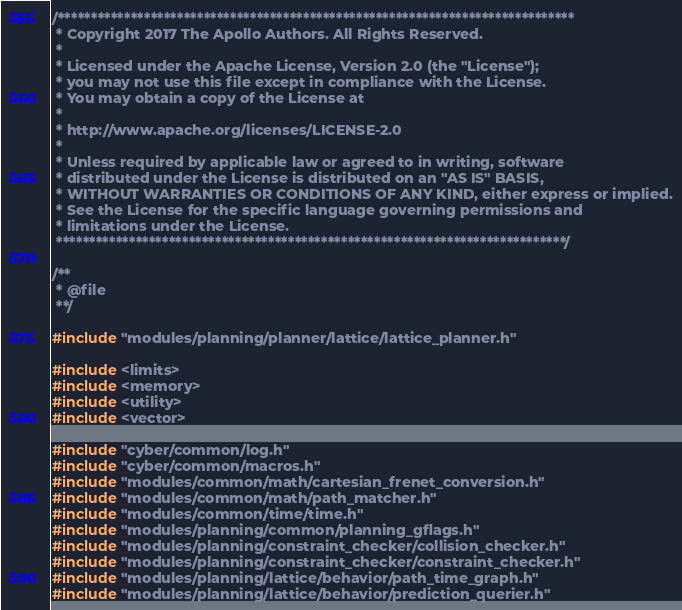<code> <loc_0><loc_0><loc_500><loc_500><_C++_>/******************************************************************************
 * Copyright 2017 The Apollo Authors. All Rights Reserved.
 *
 * Licensed under the Apache License, Version 2.0 (the "License");
 * you may not use this file except in compliance with the License.
 * You may obtain a copy of the License at
 *
 * http://www.apache.org/licenses/LICENSE-2.0
 *
 * Unless required by applicable law or agreed to in writing, software
 * distributed under the License is distributed on an "AS IS" BASIS,
 * WITHOUT WARRANTIES OR CONDITIONS OF ANY KIND, either express or implied.
 * See the License for the specific language governing permissions and
 * limitations under the License.
 *****************************************************************************/

/**
 * @file
 **/

#include "modules/planning/planner/lattice/lattice_planner.h"

#include <limits>
#include <memory>
#include <utility>
#include <vector>

#include "cyber/common/log.h"
#include "cyber/common/macros.h"
#include "modules/common/math/cartesian_frenet_conversion.h"
#include "modules/common/math/path_matcher.h"
#include "modules/common/time/time.h"
#include "modules/planning/common/planning_gflags.h"
#include "modules/planning/constraint_checker/collision_checker.h"
#include "modules/planning/constraint_checker/constraint_checker.h"
#include "modules/planning/lattice/behavior/path_time_graph.h"
#include "modules/planning/lattice/behavior/prediction_querier.h"</code> 